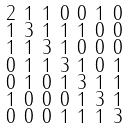Convert formula to latex. <formula><loc_0><loc_0><loc_500><loc_500>\begin{smallmatrix} 2 & 1 & 1 & 0 & 0 & 1 & 0 \\ 1 & 3 & 1 & 1 & 1 & 0 & 0 \\ 1 & 1 & 3 & 1 & 0 & 0 & 0 \\ 0 & 1 & 1 & 3 & 1 & 0 & 1 \\ 0 & 1 & 0 & 1 & 3 & 1 & 1 \\ 1 & 0 & 0 & 0 & 1 & 3 & 1 \\ 0 & 0 & 0 & 1 & 1 & 1 & 3 \end{smallmatrix}</formula> 